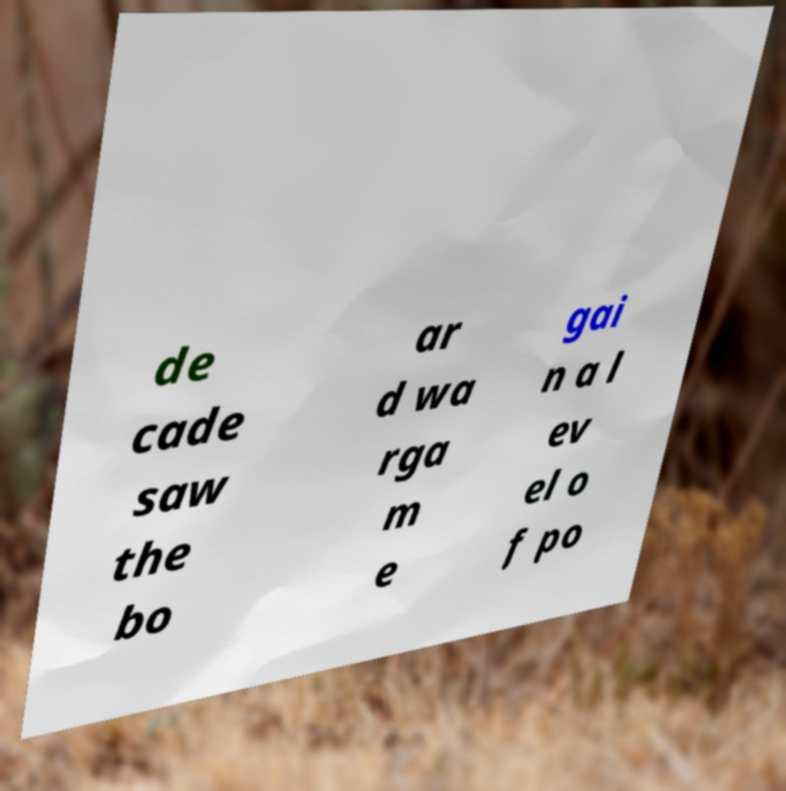Can you read and provide the text displayed in the image?This photo seems to have some interesting text. Can you extract and type it out for me? de cade saw the bo ar d wa rga m e gai n a l ev el o f po 